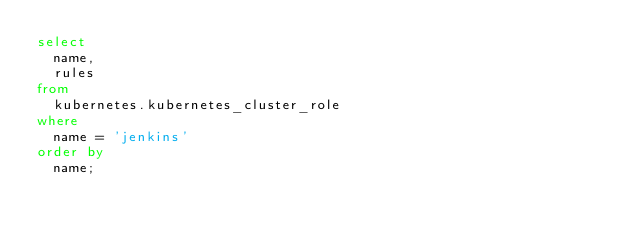Convert code to text. <code><loc_0><loc_0><loc_500><loc_500><_SQL_>select
  name,
  rules
from
  kubernetes.kubernetes_cluster_role
where
  name = 'jenkins'
order by
  name;

</code> 